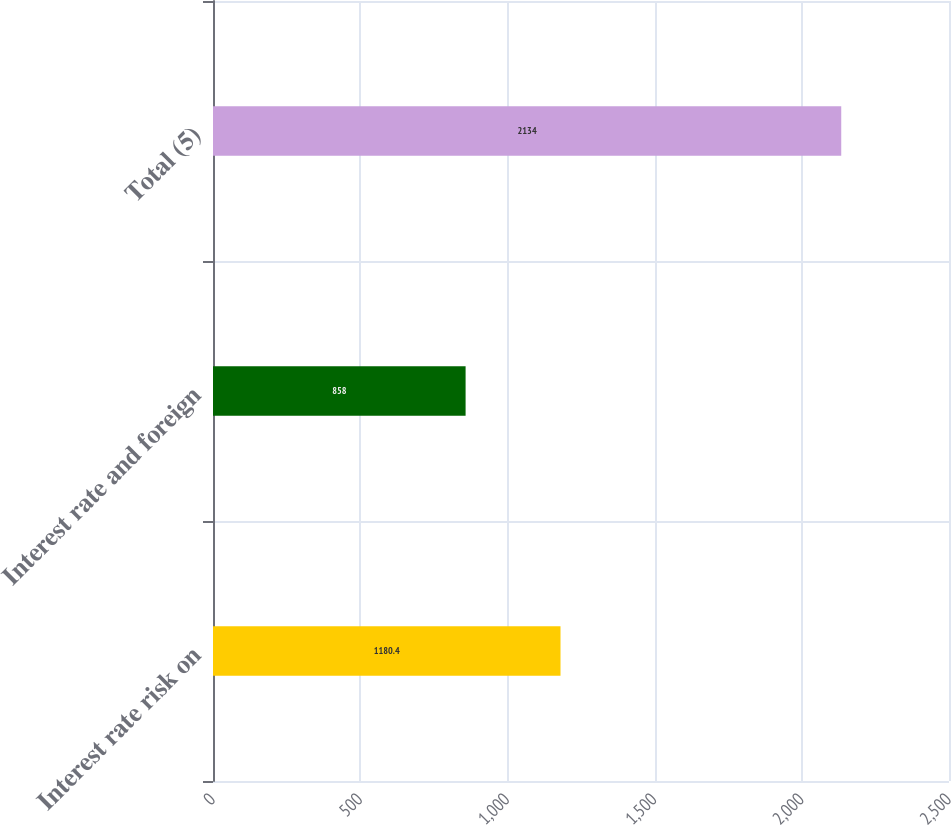<chart> <loc_0><loc_0><loc_500><loc_500><bar_chart><fcel>Interest rate risk on<fcel>Interest rate and foreign<fcel>Total (5)<nl><fcel>1180.4<fcel>858<fcel>2134<nl></chart> 